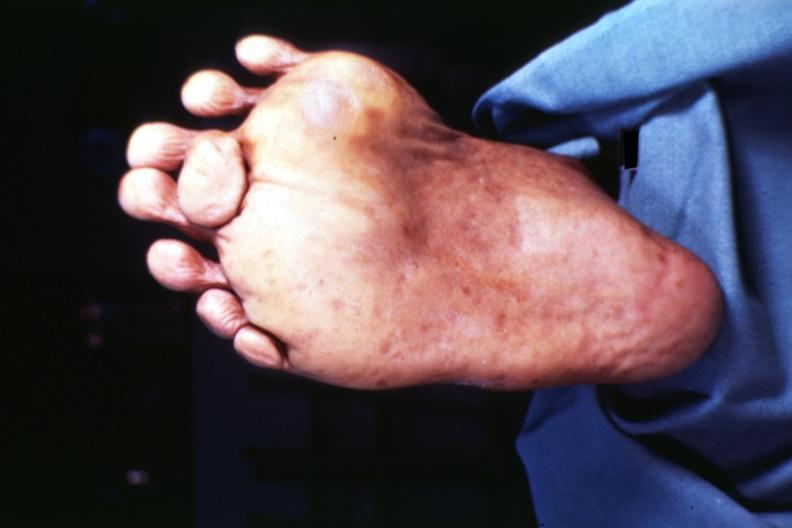how many toes does this image show view of foot from plantar surface at least?
Answer the question using a single word or phrase. 7 